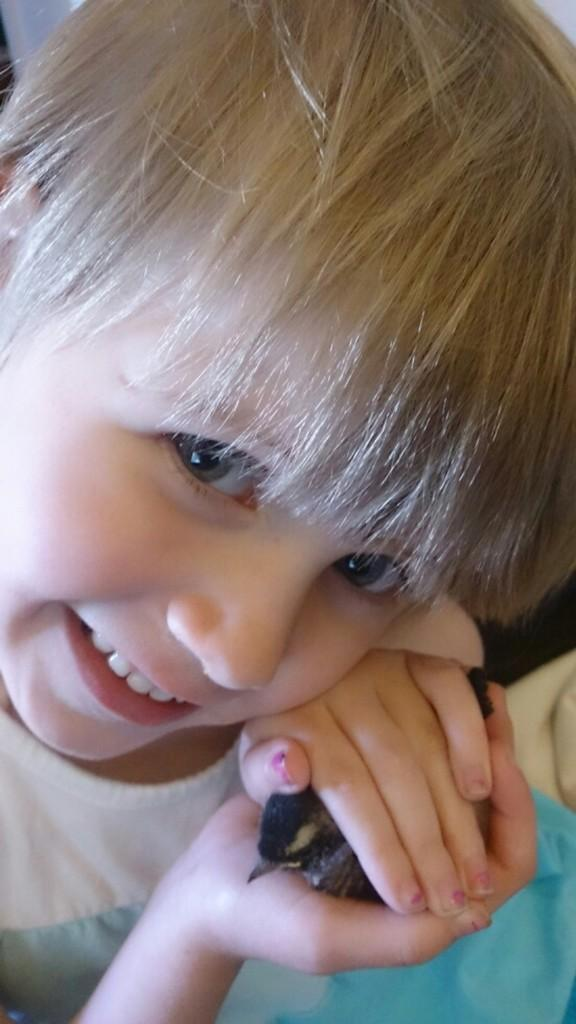What is the main subject of the image? There is a child in the image. What is the child's expression in the image? The child is smiling. What is the child holding in the image? The child is holding an object with both hands. Can you describe the background of the image? There is an object in the background of the image. What type of neck accessory is the child wearing in the image? There is no neck accessory visible on the child in the image. How does the pail help the child in the image? There is no pail present in the image, so it cannot help the child. 